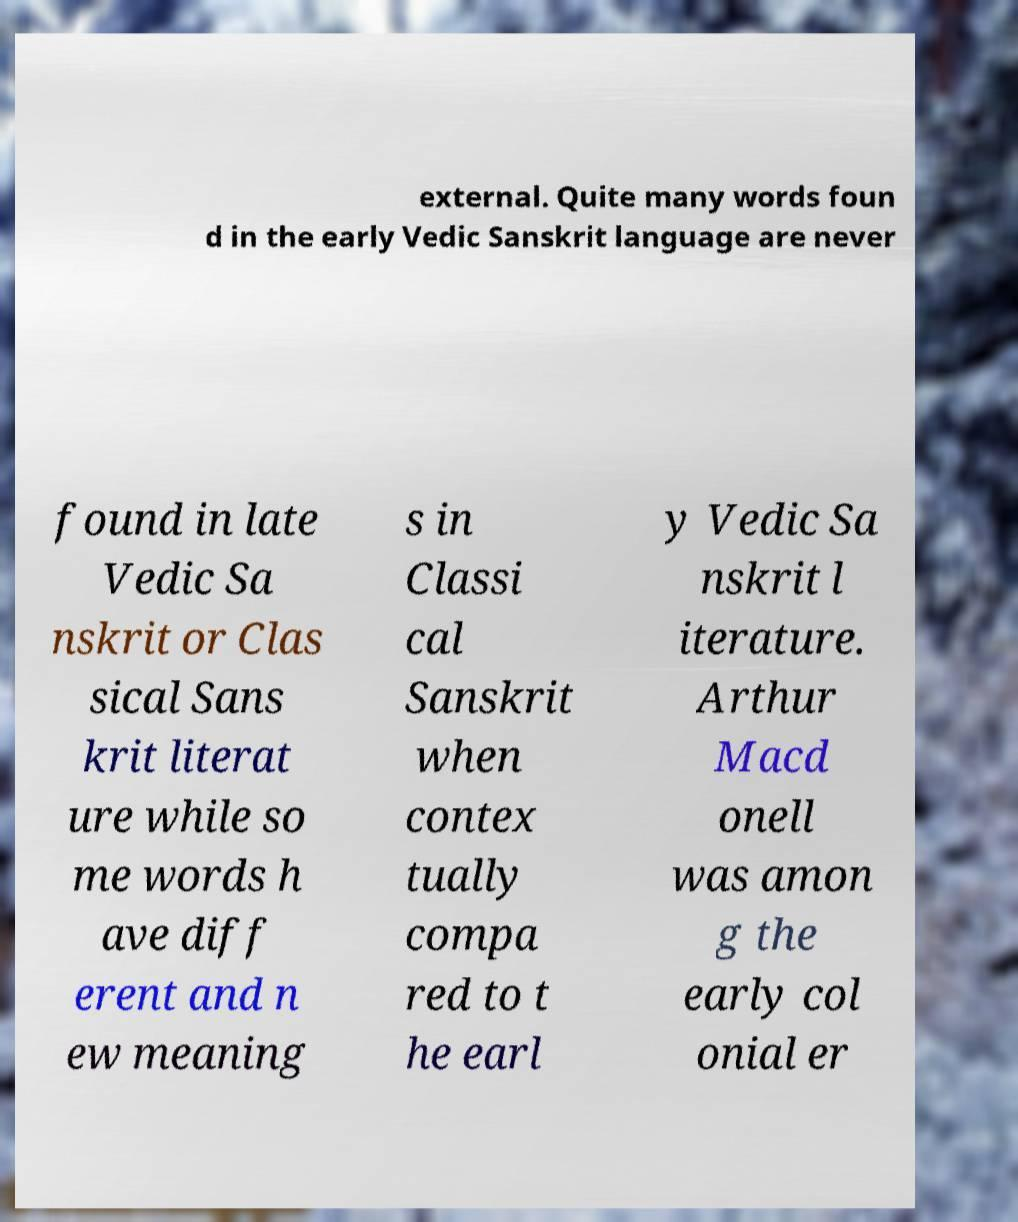There's text embedded in this image that I need extracted. Can you transcribe it verbatim? external. Quite many words foun d in the early Vedic Sanskrit language are never found in late Vedic Sa nskrit or Clas sical Sans krit literat ure while so me words h ave diff erent and n ew meaning s in Classi cal Sanskrit when contex tually compa red to t he earl y Vedic Sa nskrit l iterature. Arthur Macd onell was amon g the early col onial er 